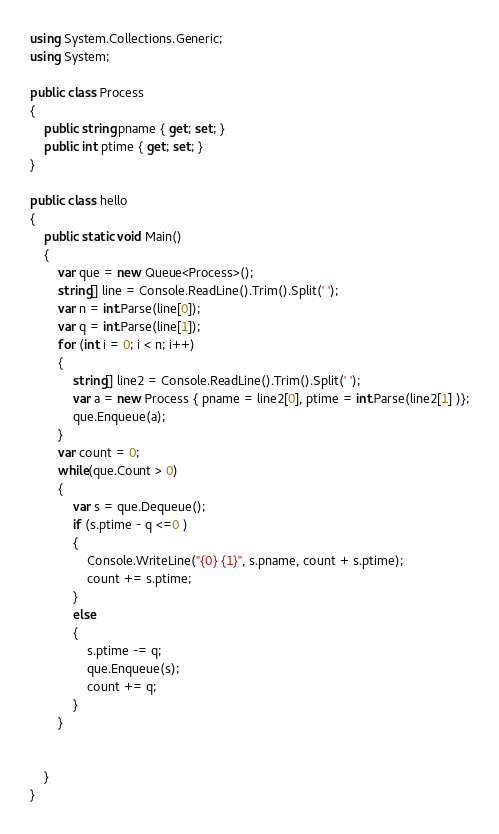Convert code to text. <code><loc_0><loc_0><loc_500><loc_500><_C#_>using System.Collections.Generic;
using System;

public class Process
{
    public string pname { get; set; }
    public int ptime { get; set; }
}

public class hello
{
    public static void Main()
    {
        var que = new Queue<Process>();
        string[] line = Console.ReadLine().Trim().Split(' ');
        var n = int.Parse(line[0]);
        var q = int.Parse(line[1]);
        for (int i = 0; i < n; i++)
        {
            string[] line2 = Console.ReadLine().Trim().Split(' ');
            var a = new Process { pname = line2[0], ptime = int.Parse(line2[1] )};
            que.Enqueue(a);
        }
        var count = 0;
        while(que.Count > 0)
        {
            var s = que.Dequeue();
            if (s.ptime - q <=0 )
            {
                Console.WriteLine("{0} {1}", s.pname, count + s.ptime);
                count += s.ptime;
            }
            else
            {
                s.ptime -= q;
                que.Enqueue(s);
                count += q;
            }
        }


    }
}</code> 